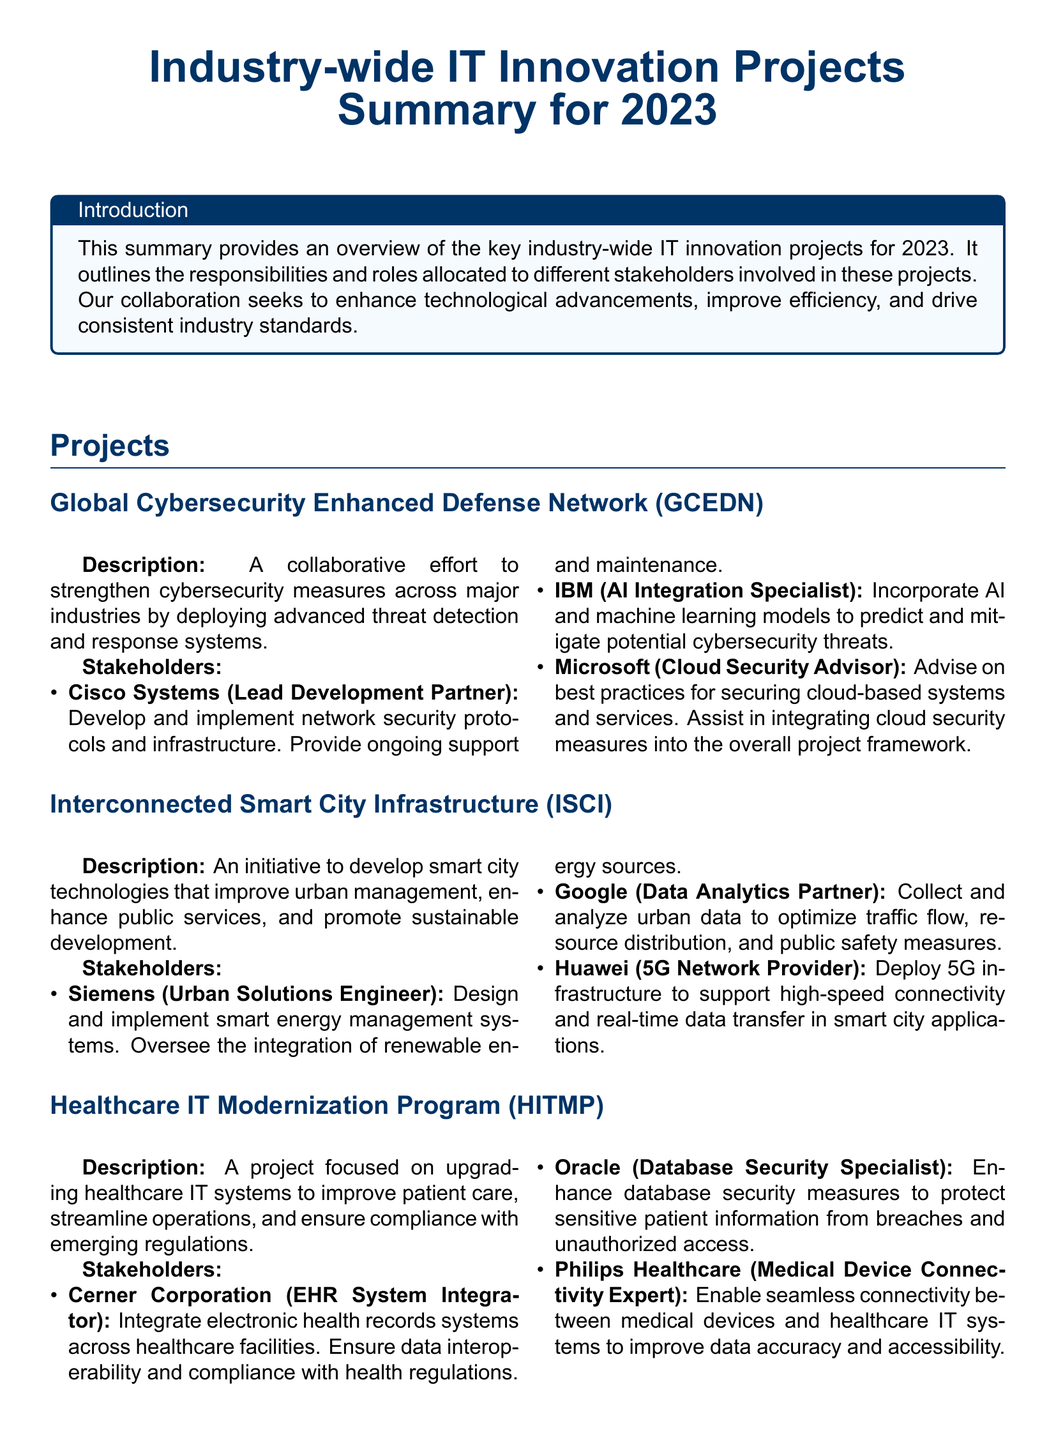What is the title of the document? The title of the document, as stated at the beginning, is "Industry-wide IT Innovation Projects Summary for 2023."
Answer: Industry-wide IT Innovation Projects Summary for 2023 How many main projects are listed in the document? The document lists three main projects under the section "Projects."
Answer: 3 Who is the lead development partner for the Global Cybersecurity Enhanced Defense Network? The lead development partner for this project is identified as Cisco Systems.
Answer: Cisco Systems What role does IBM have in the Global Cybersecurity Enhanced Defense Network project? IBM is designated as the AI Integration Specialist responsible for incorporating AI and machine learning models into the project.
Answer: AI Integration Specialist Which company is responsible for designing smart energy management systems in the Interconnected Smart City Infrastructure project? Siemens is responsible for designing smart energy management systems in this project.
Answer: Siemens What is the focus of the Healthcare IT Modernization Program? The focus of this program is on upgrading healthcare IT systems.
Answer: Upgrading healthcare IT systems Which responsibility is assigned to Oracle in the Healthcare IT Modernization Program? Oracle's responsibility is to enhance database security measures.
Answer: Enhance database security measures What type of technology does Huawei provide for the Interconnected Smart City Infrastructure? Huawei provides 5G infrastructure technology for this project.
Answer: 5G infrastructure What is the purpose of the summary? The purpose of the summary is to provide an overview of the key industry-wide IT innovation projects for 2023.
Answer: Overview of the key industry-wide IT innovation projects for 2023 